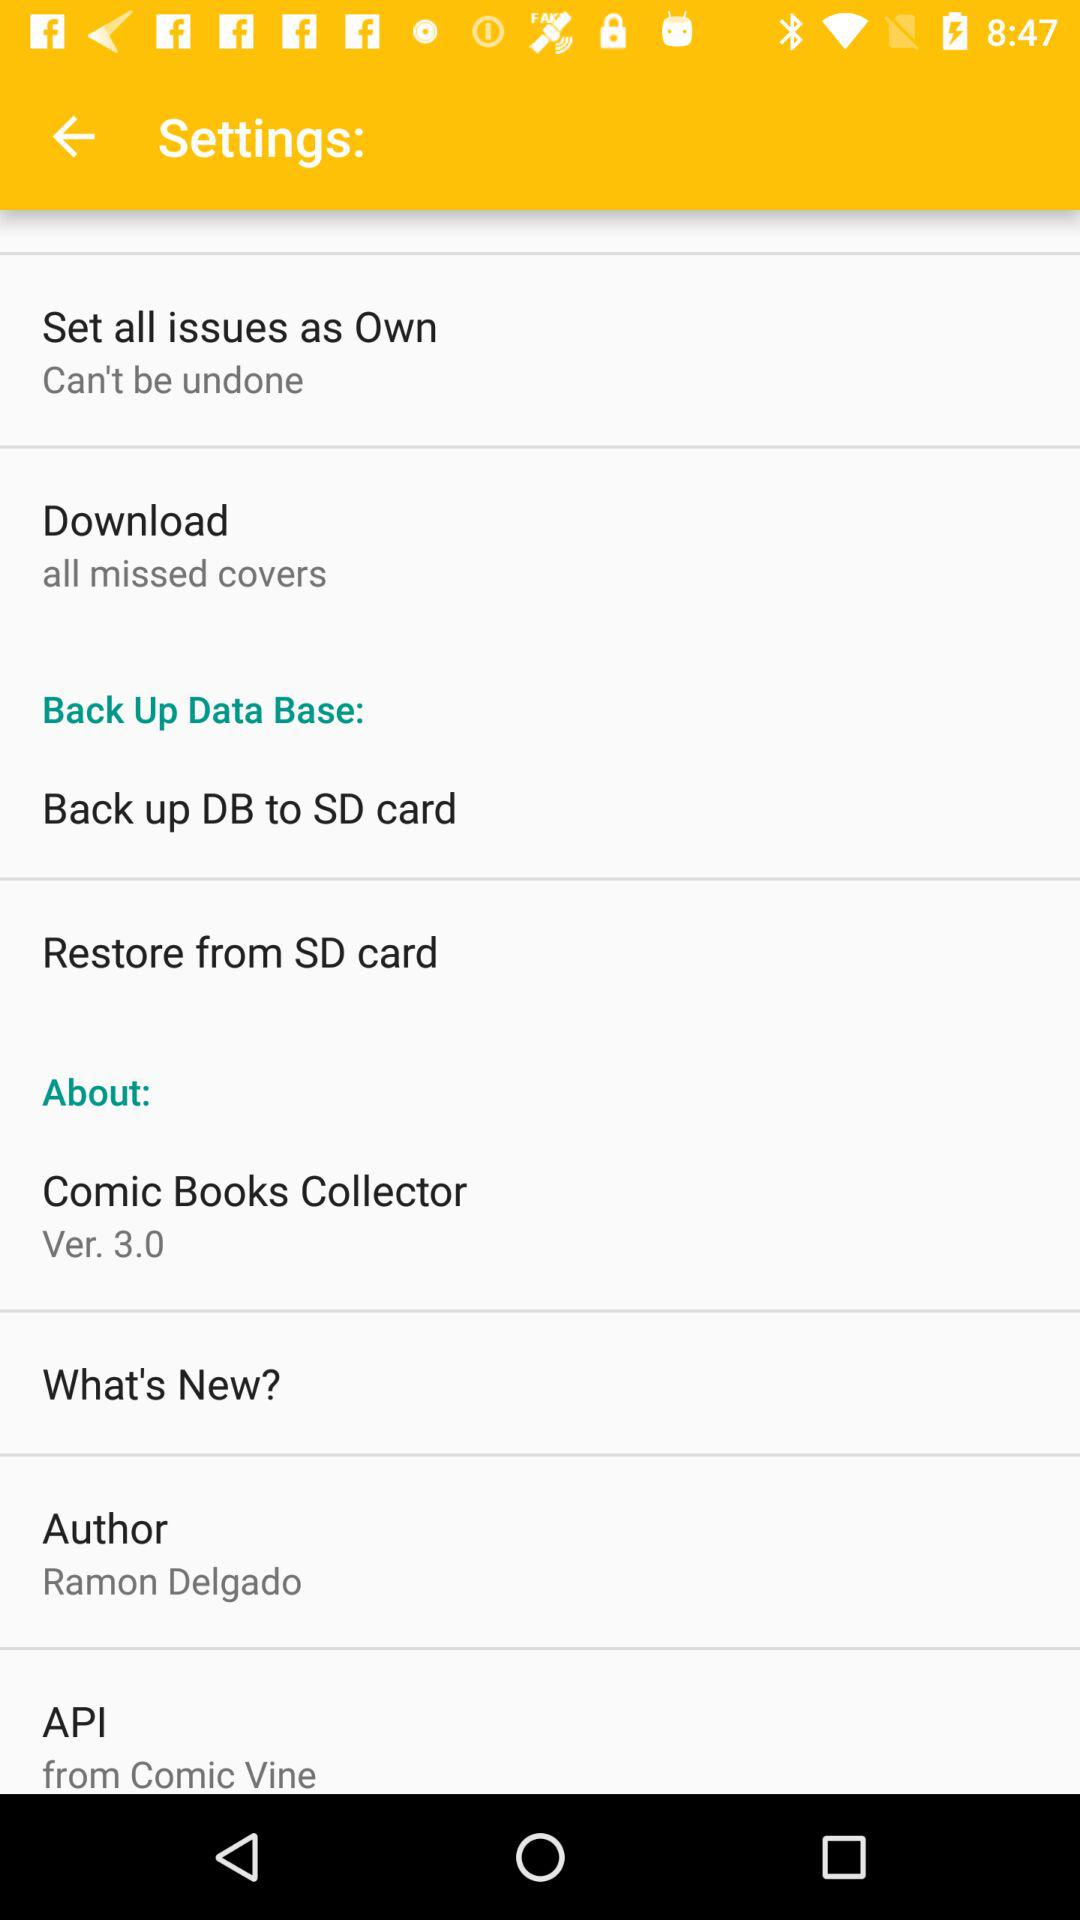What is the version of "Comic Books Collector"? The version is 3.0. 